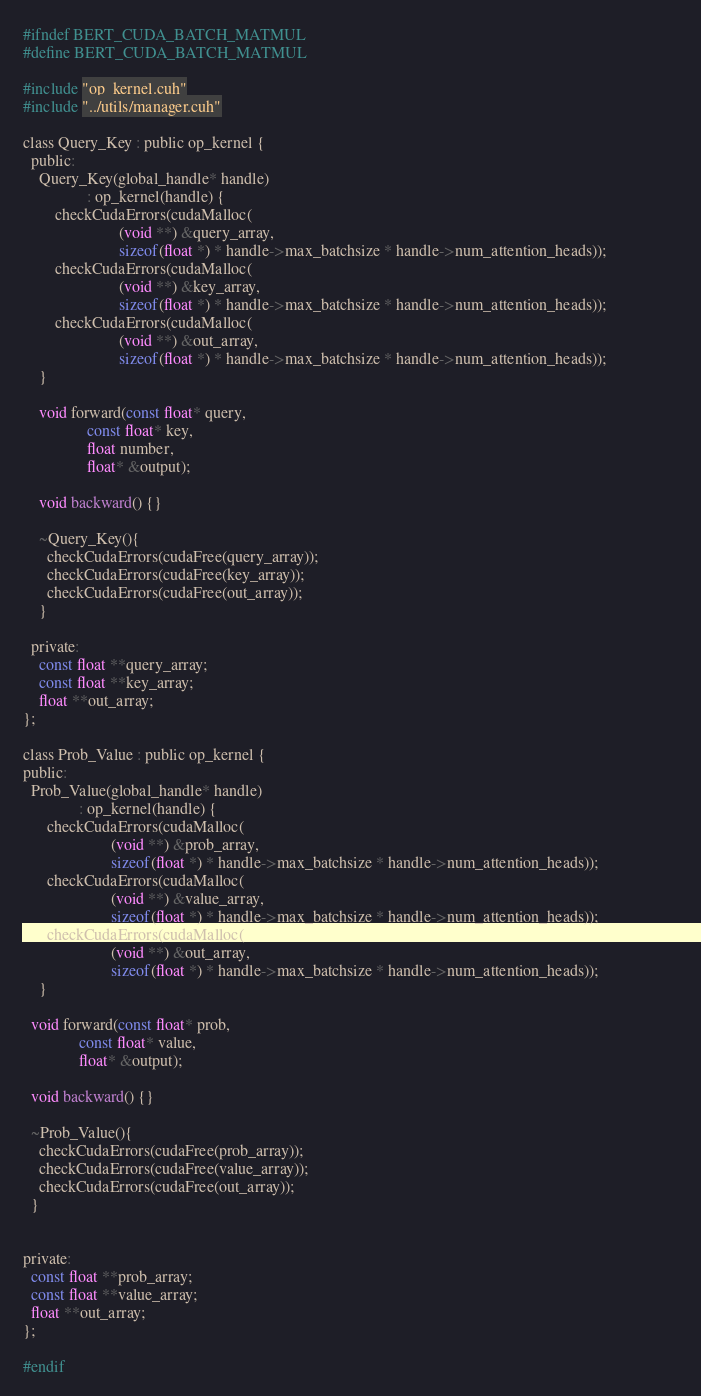<code> <loc_0><loc_0><loc_500><loc_500><_Cuda_>#ifndef BERT_CUDA_BATCH_MATMUL
#define BERT_CUDA_BATCH_MATMUL

#include "op_kernel.cuh"
#include "../utils/manager.cuh"

class Query_Key : public op_kernel {
  public:
    Query_Key(global_handle* handle)
                : op_kernel(handle) {
        checkCudaErrors(cudaMalloc(
                        (void **) &query_array, 
                        sizeof(float *) * handle->max_batchsize * handle->num_attention_heads));
        checkCudaErrors(cudaMalloc(
                        (void **) &key_array, 
                        sizeof(float *) * handle->max_batchsize * handle->num_attention_heads));
        checkCudaErrors(cudaMalloc(
                        (void **) &out_array, 
                        sizeof(float *) * handle->max_batchsize * handle->num_attention_heads));                  
    }

    void forward(const float* query,
                const float* key,
                float number,
                float* &output);

    void backward() {}

    ~Query_Key(){
      checkCudaErrors(cudaFree(query_array));
      checkCudaErrors(cudaFree(key_array));
      checkCudaErrors(cudaFree(out_array));
    }

  private:
    const float **query_array;
    const float **key_array;
    float **out_array;
};

class Prob_Value : public op_kernel {
public:
  Prob_Value(global_handle* handle)
              : op_kernel(handle) {
      checkCudaErrors(cudaMalloc(
                      (void **) &prob_array, 
                      sizeof(float *) * handle->max_batchsize * handle->num_attention_heads));
      checkCudaErrors(cudaMalloc(
                      (void **) &value_array, 
                      sizeof(float *) * handle->max_batchsize * handle->num_attention_heads));
      checkCudaErrors(cudaMalloc(
                      (void **) &out_array, 
                      sizeof(float *) * handle->max_batchsize * handle->num_attention_heads));                  
    }

  void forward(const float* prob,
              const float* value,
              float* &output);

  void backward() {}

  ~Prob_Value(){
    checkCudaErrors(cudaFree(prob_array));
    checkCudaErrors(cudaFree(value_array));
    checkCudaErrors(cudaFree(out_array));
  }


private:
  const float **prob_array;
  const float **value_array;
  float **out_array;
};

#endif</code> 